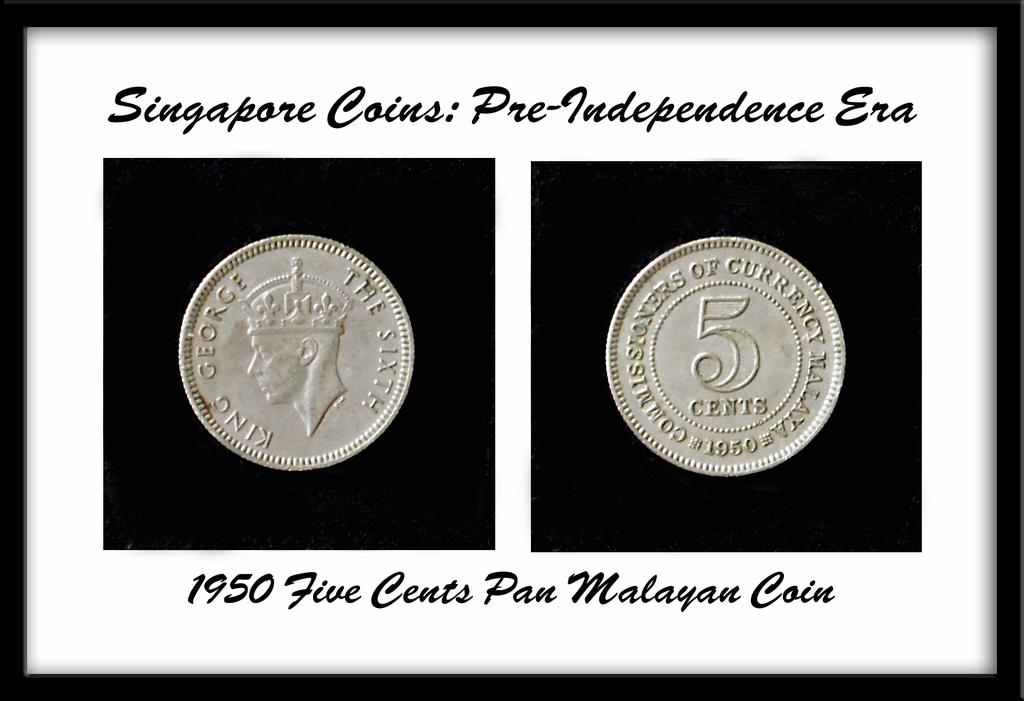Provide a one-sentence caption for the provided image. Two coins sit in a decorative box from the pre-independence era. 